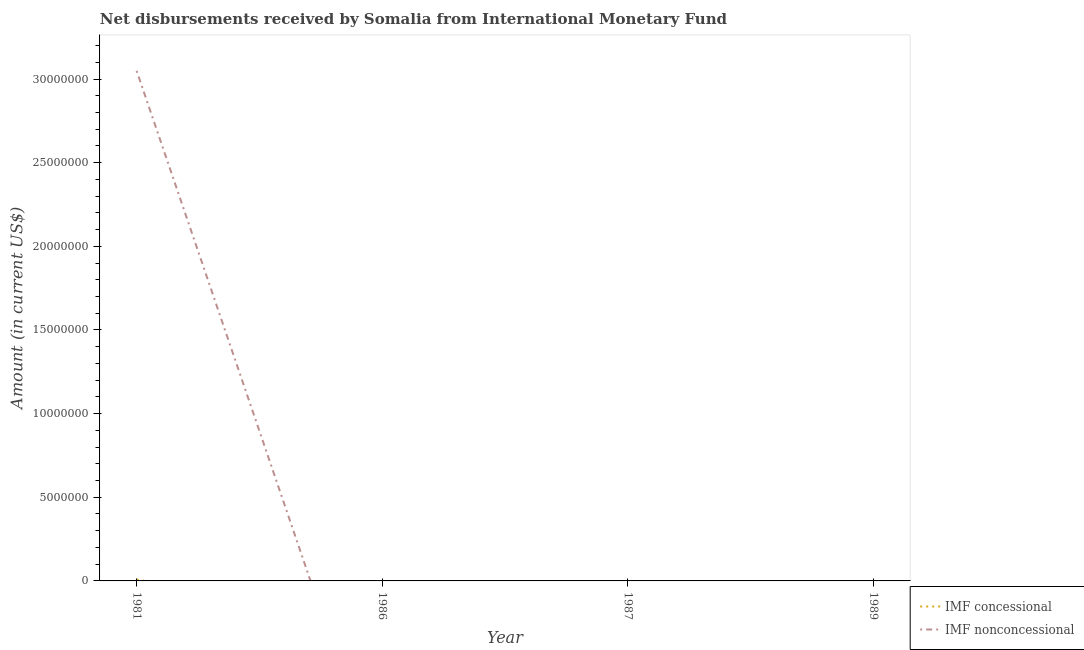Across all years, what is the maximum net concessional disbursements from imf?
Give a very brief answer. 8.50e+04. What is the total net concessional disbursements from imf in the graph?
Your response must be concise. 8.50e+04. What is the difference between the net non concessional disbursements from imf in 1989 and the net concessional disbursements from imf in 1981?
Provide a succinct answer. -8.50e+04. What is the average net non concessional disbursements from imf per year?
Your answer should be compact. 7.62e+06. In the year 1981, what is the difference between the net non concessional disbursements from imf and net concessional disbursements from imf?
Offer a very short reply. 3.04e+07. What is the difference between the highest and the lowest net concessional disbursements from imf?
Make the answer very short. 8.50e+04. In how many years, is the net non concessional disbursements from imf greater than the average net non concessional disbursements from imf taken over all years?
Offer a very short reply. 1. Is the net concessional disbursements from imf strictly less than the net non concessional disbursements from imf over the years?
Your answer should be compact. No. How many lines are there?
Keep it short and to the point. 2. What is the difference between two consecutive major ticks on the Y-axis?
Your answer should be compact. 5.00e+06. Are the values on the major ticks of Y-axis written in scientific E-notation?
Your answer should be very brief. No. Does the graph contain grids?
Ensure brevity in your answer.  No. Where does the legend appear in the graph?
Give a very brief answer. Bottom right. How many legend labels are there?
Your answer should be compact. 2. What is the title of the graph?
Offer a terse response. Net disbursements received by Somalia from International Monetary Fund. Does "Age 65(female)" appear as one of the legend labels in the graph?
Ensure brevity in your answer.  No. What is the label or title of the Y-axis?
Your answer should be very brief. Amount (in current US$). What is the Amount (in current US$) in IMF concessional in 1981?
Provide a short and direct response. 8.50e+04. What is the Amount (in current US$) of IMF nonconcessional in 1981?
Give a very brief answer. 3.05e+07. What is the Amount (in current US$) of IMF concessional in 1986?
Your response must be concise. 0. What is the Amount (in current US$) in IMF nonconcessional in 1986?
Your answer should be very brief. 0. What is the Amount (in current US$) in IMF nonconcessional in 1987?
Provide a succinct answer. 0. What is the Amount (in current US$) of IMF concessional in 1989?
Offer a terse response. 0. What is the Amount (in current US$) of IMF nonconcessional in 1989?
Make the answer very short. 0. Across all years, what is the maximum Amount (in current US$) of IMF concessional?
Give a very brief answer. 8.50e+04. Across all years, what is the maximum Amount (in current US$) in IMF nonconcessional?
Your answer should be very brief. 3.05e+07. Across all years, what is the minimum Amount (in current US$) of IMF concessional?
Offer a very short reply. 0. What is the total Amount (in current US$) of IMF concessional in the graph?
Offer a terse response. 8.50e+04. What is the total Amount (in current US$) in IMF nonconcessional in the graph?
Give a very brief answer. 3.05e+07. What is the average Amount (in current US$) in IMF concessional per year?
Make the answer very short. 2.12e+04. What is the average Amount (in current US$) in IMF nonconcessional per year?
Offer a terse response. 7.62e+06. In the year 1981, what is the difference between the Amount (in current US$) in IMF concessional and Amount (in current US$) in IMF nonconcessional?
Make the answer very short. -3.04e+07. What is the difference between the highest and the lowest Amount (in current US$) of IMF concessional?
Your response must be concise. 8.50e+04. What is the difference between the highest and the lowest Amount (in current US$) in IMF nonconcessional?
Provide a short and direct response. 3.05e+07. 